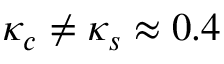<formula> <loc_0><loc_0><loc_500><loc_500>\kappa _ { c } \neq \kappa _ { s } \approx 0 . 4</formula> 